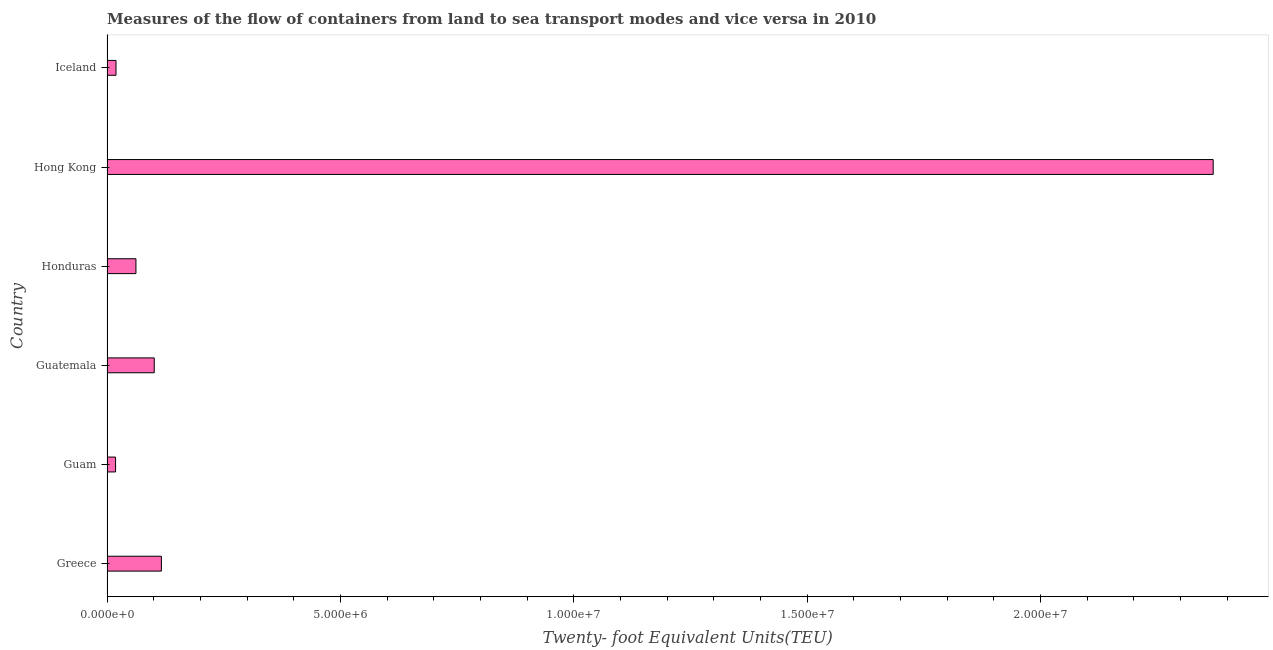What is the title of the graph?
Your answer should be compact. Measures of the flow of containers from land to sea transport modes and vice versa in 2010. What is the label or title of the X-axis?
Provide a short and direct response. Twenty- foot Equivalent Units(TEU). What is the label or title of the Y-axis?
Provide a succinct answer. Country. What is the container port traffic in Iceland?
Provide a short and direct response. 1.93e+05. Across all countries, what is the maximum container port traffic?
Offer a terse response. 2.37e+07. Across all countries, what is the minimum container port traffic?
Your answer should be very brief. 1.83e+05. In which country was the container port traffic maximum?
Offer a very short reply. Hong Kong. In which country was the container port traffic minimum?
Offer a terse response. Guam. What is the sum of the container port traffic?
Provide a short and direct response. 2.69e+07. What is the difference between the container port traffic in Honduras and Iceland?
Offer a very short reply. 4.27e+05. What is the average container port traffic per country?
Offer a very short reply. 4.48e+06. What is the median container port traffic?
Offer a very short reply. 8.16e+05. What is the ratio of the container port traffic in Guatemala to that in Honduras?
Give a very brief answer. 1.63. Is the container port traffic in Guam less than that in Iceland?
Offer a very short reply. Yes. Is the difference between the container port traffic in Guam and Guatemala greater than the difference between any two countries?
Provide a succinct answer. No. What is the difference between the highest and the second highest container port traffic?
Ensure brevity in your answer.  2.25e+07. Is the sum of the container port traffic in Greece and Honduras greater than the maximum container port traffic across all countries?
Provide a short and direct response. No. What is the difference between the highest and the lowest container port traffic?
Keep it short and to the point. 2.35e+07. In how many countries, is the container port traffic greater than the average container port traffic taken over all countries?
Your response must be concise. 1. Are all the bars in the graph horizontal?
Offer a terse response. Yes. How many countries are there in the graph?
Provide a short and direct response. 6. What is the difference between two consecutive major ticks on the X-axis?
Make the answer very short. 5.00e+06. Are the values on the major ticks of X-axis written in scientific E-notation?
Your answer should be compact. Yes. What is the Twenty- foot Equivalent Units(TEU) in Greece?
Make the answer very short. 1.17e+06. What is the Twenty- foot Equivalent Units(TEU) in Guam?
Your response must be concise. 1.83e+05. What is the Twenty- foot Equivalent Units(TEU) in Guatemala?
Offer a terse response. 1.01e+06. What is the Twenty- foot Equivalent Units(TEU) in Honduras?
Keep it short and to the point. 6.20e+05. What is the Twenty- foot Equivalent Units(TEU) of Hong Kong?
Ensure brevity in your answer.  2.37e+07. What is the Twenty- foot Equivalent Units(TEU) in Iceland?
Offer a terse response. 1.93e+05. What is the difference between the Twenty- foot Equivalent Units(TEU) in Greece and Guam?
Provide a short and direct response. 9.82e+05. What is the difference between the Twenty- foot Equivalent Units(TEU) in Greece and Guatemala?
Provide a short and direct response. 1.53e+05. What is the difference between the Twenty- foot Equivalent Units(TEU) in Greece and Honduras?
Your answer should be compact. 5.45e+05. What is the difference between the Twenty- foot Equivalent Units(TEU) in Greece and Hong Kong?
Your answer should be very brief. -2.25e+07. What is the difference between the Twenty- foot Equivalent Units(TEU) in Greece and Iceland?
Your response must be concise. 9.72e+05. What is the difference between the Twenty- foot Equivalent Units(TEU) in Guam and Guatemala?
Offer a very short reply. -8.29e+05. What is the difference between the Twenty- foot Equivalent Units(TEU) in Guam and Honduras?
Keep it short and to the point. -4.37e+05. What is the difference between the Twenty- foot Equivalent Units(TEU) in Guam and Hong Kong?
Your answer should be very brief. -2.35e+07. What is the difference between the Twenty- foot Equivalent Units(TEU) in Guam and Iceland?
Ensure brevity in your answer.  -9564. What is the difference between the Twenty- foot Equivalent Units(TEU) in Guatemala and Honduras?
Make the answer very short. 3.92e+05. What is the difference between the Twenty- foot Equivalent Units(TEU) in Guatemala and Hong Kong?
Ensure brevity in your answer.  -2.27e+07. What is the difference between the Twenty- foot Equivalent Units(TEU) in Guatemala and Iceland?
Keep it short and to the point. 8.20e+05. What is the difference between the Twenty- foot Equivalent Units(TEU) in Honduras and Hong Kong?
Your response must be concise. -2.31e+07. What is the difference between the Twenty- foot Equivalent Units(TEU) in Honduras and Iceland?
Provide a succinct answer. 4.27e+05. What is the difference between the Twenty- foot Equivalent Units(TEU) in Hong Kong and Iceland?
Give a very brief answer. 2.35e+07. What is the ratio of the Twenty- foot Equivalent Units(TEU) in Greece to that in Guam?
Your response must be concise. 6.36. What is the ratio of the Twenty- foot Equivalent Units(TEU) in Greece to that in Guatemala?
Offer a very short reply. 1.15. What is the ratio of the Twenty- foot Equivalent Units(TEU) in Greece to that in Honduras?
Provide a succinct answer. 1.88. What is the ratio of the Twenty- foot Equivalent Units(TEU) in Greece to that in Hong Kong?
Offer a very short reply. 0.05. What is the ratio of the Twenty- foot Equivalent Units(TEU) in Greece to that in Iceland?
Offer a terse response. 6.04. What is the ratio of the Twenty- foot Equivalent Units(TEU) in Guam to that in Guatemala?
Give a very brief answer. 0.18. What is the ratio of the Twenty- foot Equivalent Units(TEU) in Guam to that in Honduras?
Offer a very short reply. 0.3. What is the ratio of the Twenty- foot Equivalent Units(TEU) in Guam to that in Hong Kong?
Offer a very short reply. 0.01. What is the ratio of the Twenty- foot Equivalent Units(TEU) in Guatemala to that in Honduras?
Your answer should be very brief. 1.63. What is the ratio of the Twenty- foot Equivalent Units(TEU) in Guatemala to that in Hong Kong?
Keep it short and to the point. 0.04. What is the ratio of the Twenty- foot Equivalent Units(TEU) in Guatemala to that in Iceland?
Your answer should be compact. 5.25. What is the ratio of the Twenty- foot Equivalent Units(TEU) in Honduras to that in Hong Kong?
Offer a terse response. 0.03. What is the ratio of the Twenty- foot Equivalent Units(TEU) in Honduras to that in Iceland?
Provide a short and direct response. 3.21. What is the ratio of the Twenty- foot Equivalent Units(TEU) in Hong Kong to that in Iceland?
Offer a very short reply. 122.94. 